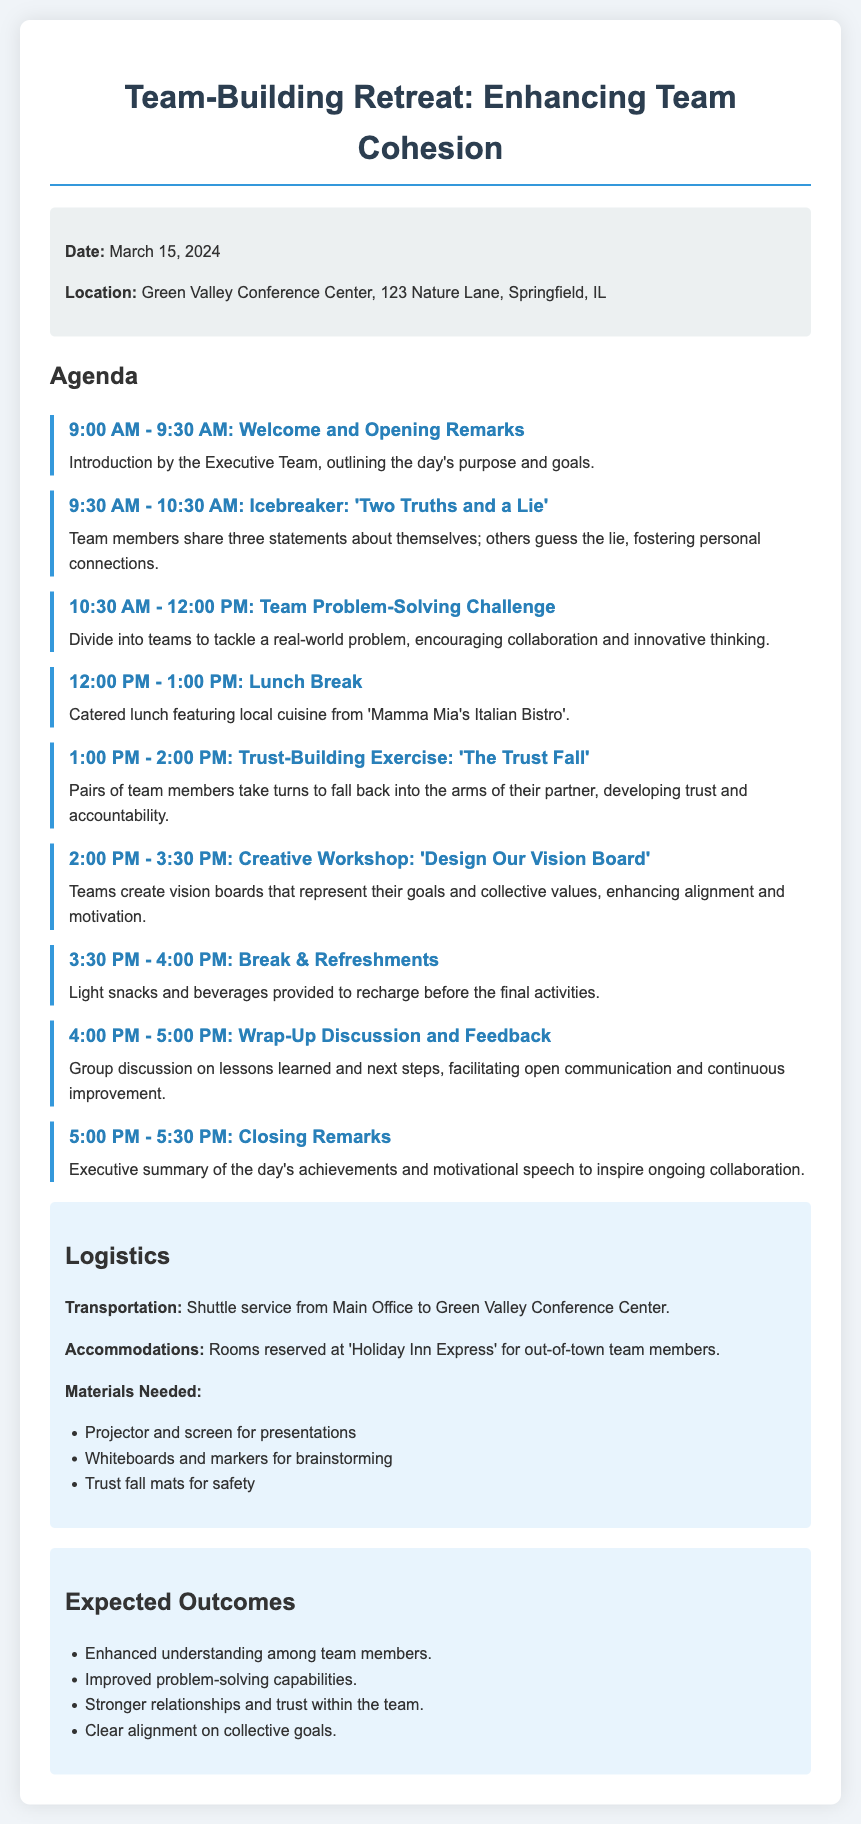What is the date of the team-building retreat? The date is specified in the event information section of the document.
Answer: March 15, 2024 Where is the event location? The location details are provided in the event information section.
Answer: Green Valley Conference Center, 123 Nature Lane, Springfield, IL What activity starts at 9:30 AM? The agenda lists the activities by their start times.
Answer: Icebreaker: 'Two Truths and a Lie' What type of food will be served during lunch? The lunch details are mentioned in the agenda item for the lunch break.
Answer: Local cuisine from 'Mamma Mia's Italian Bistro' What is the last activity mentioned in the agenda? Reviewing the agenda, the last activity that concludes the day's events is stated.
Answer: Closing Remarks What is one expected outcome of the retreat? The outcomes are listed in the corresponding section, each emphasizing team development.
Answer: Enhanced understanding among team members How long is the scheduled break for refreshments? The duration of the break is specifically noted in the agenda.
Answer: 30 minutes What materials are needed for the trust-building exercise? Referring to the logistics section, the needed materials are clearly explained.
Answer: Trust fall mats for safety What is provided for transportation? The logistics section outlines transportation arrangements for the event.
Answer: Shuttle service from Main Office to Green Valley Conference Center 